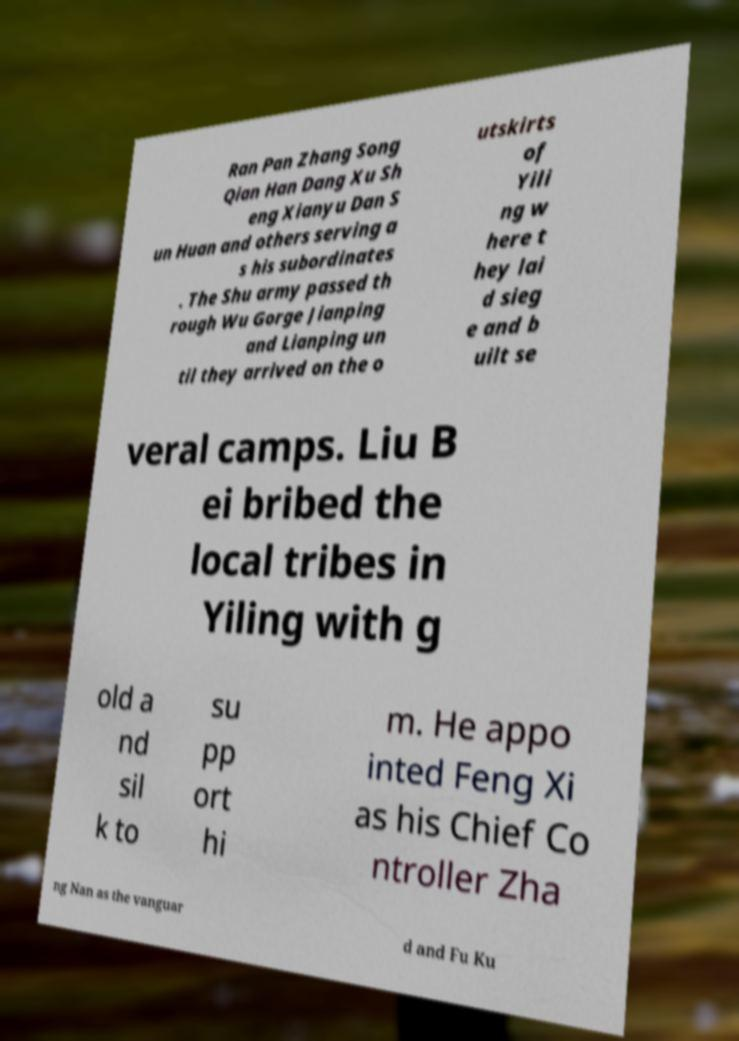For documentation purposes, I need the text within this image transcribed. Could you provide that? Ran Pan Zhang Song Qian Han Dang Xu Sh eng Xianyu Dan S un Huan and others serving a s his subordinates . The Shu army passed th rough Wu Gorge Jianping and Lianping un til they arrived on the o utskirts of Yili ng w here t hey lai d sieg e and b uilt se veral camps. Liu B ei bribed the local tribes in Yiling with g old a nd sil k to su pp ort hi m. He appo inted Feng Xi as his Chief Co ntroller Zha ng Nan as the vanguar d and Fu Ku 